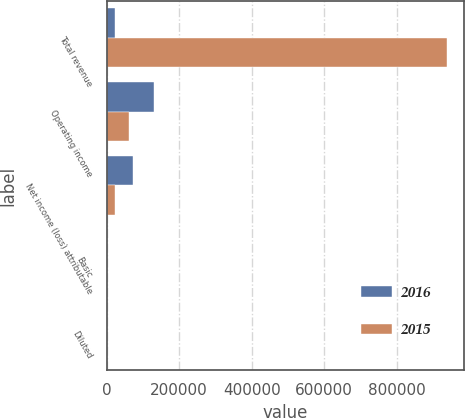<chart> <loc_0><loc_0><loc_500><loc_500><stacked_bar_chart><ecel><fcel>Total revenue<fcel>Operating income<fcel>Net income (loss) attributable<fcel>Basic<fcel>Diluted<nl><fcel>2016<fcel>21456<fcel>131282<fcel>73229<fcel>0.32<fcel>0.32<nl><fcel>2015<fcel>938182<fcel>60349<fcel>21456<fcel>0.1<fcel>0.1<nl></chart> 